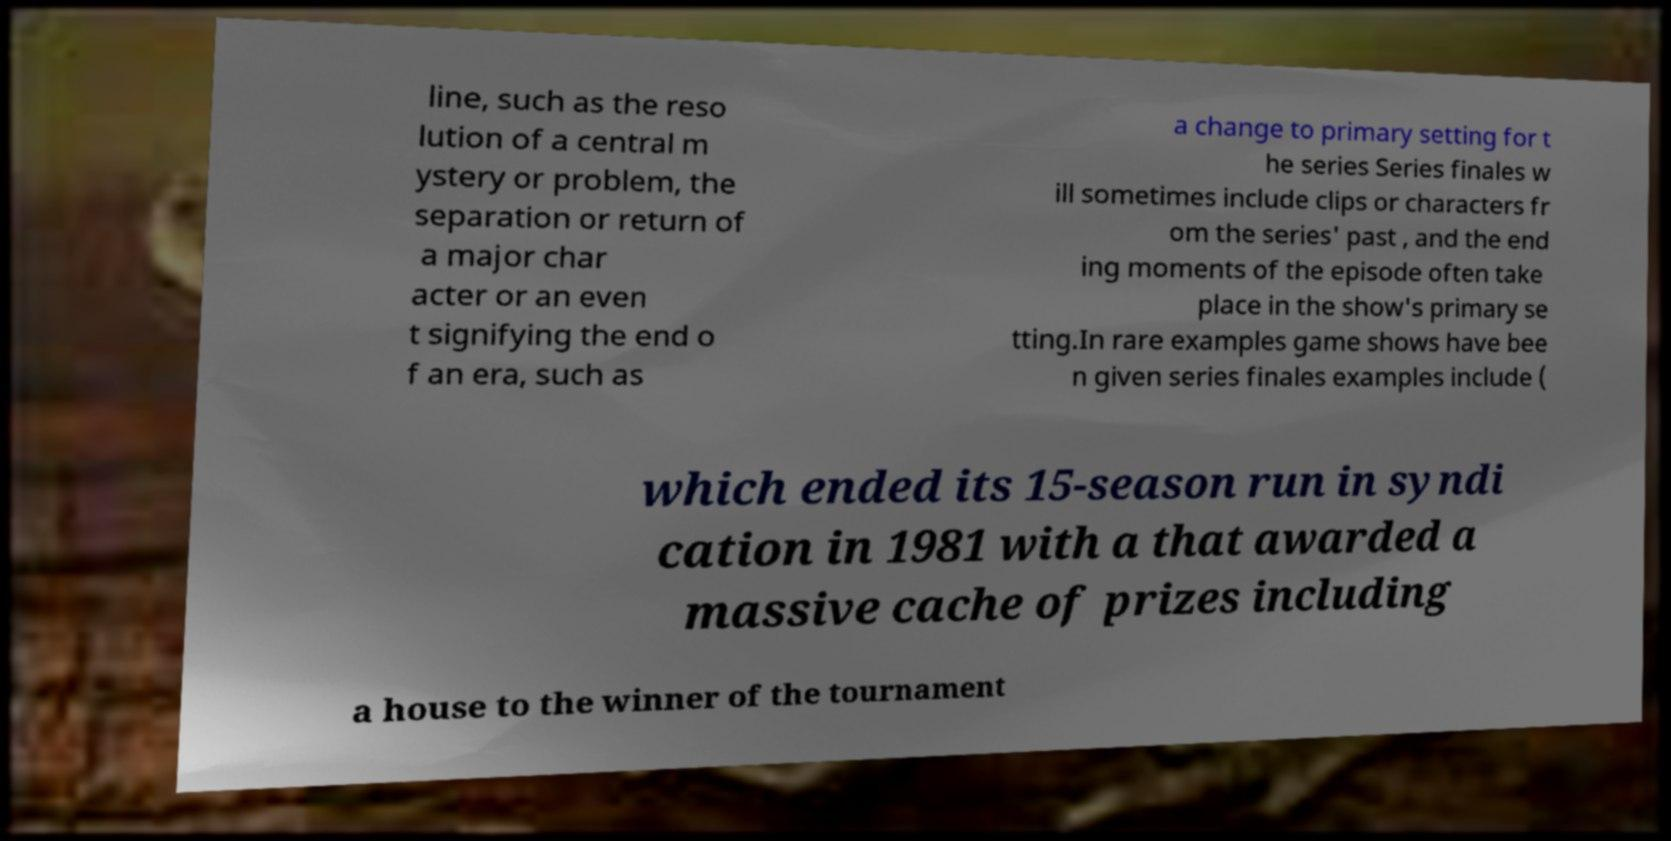What messages or text are displayed in this image? I need them in a readable, typed format. line, such as the reso lution of a central m ystery or problem, the separation or return of a major char acter or an even t signifying the end o f an era, such as a change to primary setting for t he series Series finales w ill sometimes include clips or characters fr om the series' past , and the end ing moments of the episode often take place in the show's primary se tting.In rare examples game shows have bee n given series finales examples include ( which ended its 15-season run in syndi cation in 1981 with a that awarded a massive cache of prizes including a house to the winner of the tournament 